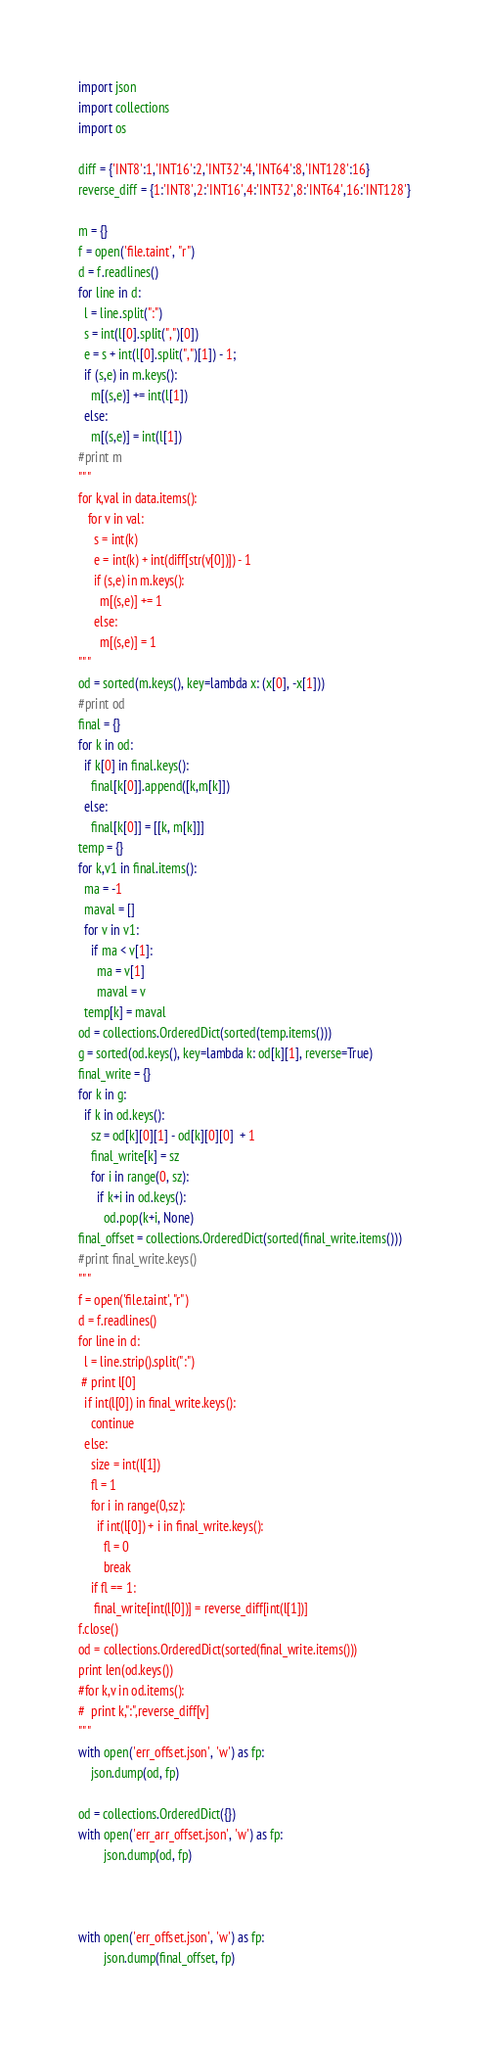<code> <loc_0><loc_0><loc_500><loc_500><_Python_>import json
import collections
import os

diff = {'INT8':1,'INT16':2,'INT32':4,'INT64':8,'INT128':16}
reverse_diff = {1:'INT8',2:'INT16',4:'INT32',8:'INT64',16:'INT128'}

m = {}
f = open('file.taint', "r")
d = f.readlines()
for line in d:
  l = line.split(":")
  s = int(l[0].split(",")[0])
  e = s + int(l[0].split(",")[1]) - 1;
  if (s,e) in m.keys():
    m[(s,e)] += int(l[1])
  else:
    m[(s,e)] = int(l[1])
#print m
"""
for k,val in data.items():
   for v in val:
     s = int(k)
     e = int(k) + int(diff[str(v[0])]) - 1
     if (s,e) in m.keys():
       m[(s,e)] += 1
     else:
       m[(s,e)] = 1
"""
od = sorted(m.keys(), key=lambda x: (x[0], -x[1]))
#print od
final = {}
for k in od:
  if k[0] in final.keys():
    final[k[0]].append([k,m[k]])
  else:
    final[k[0]] = [[k, m[k]]]
temp = {}
for k,v1 in final.items():
  ma = -1
  maval = []
  for v in v1:
    if ma < v[1]:
      ma = v[1]
      maval = v
  temp[k] = maval
od = collections.OrderedDict(sorted(temp.items()))
g = sorted(od.keys(), key=lambda k: od[k][1], reverse=True)
final_write = {}
for k in g:
  if k in od.keys():
    sz = od[k][0][1] - od[k][0][0]  + 1
    final_write[k] = sz
    for i in range(0, sz):
      if k+i in od.keys():
        od.pop(k+i, None)
final_offset = collections.OrderedDict(sorted(final_write.items()))
#print final_write.keys()
"""
f = open('file.taint', "r")
d = f.readlines()
for line in d:
  l = line.strip().split(":")
 # print l[0]
  if int(l[0]) in final_write.keys():
    continue
  else:
    size = int(l[1])
    fl = 1
    for i in range(0,sz):
      if int(l[0]) + i in final_write.keys():
        fl = 0
        break
    if fl == 1:
     final_write[int(l[0])] = reverse_diff[int(l[1])]
f.close()
od = collections.OrderedDict(sorted(final_write.items()))
print len(od.keys())
#for k,v in od.items():
#  print k,":",reverse_diff[v]
"""
with open('err_offset.json', 'w') as fp:
	json.dump(od, fp)

od = collections.OrderedDict({})
with open('err_arr_offset.json', 'w') as fp:
        json.dump(od, fp)



with open('err_offset.json', 'w') as fp:
        json.dump(final_offset, fp)
</code> 